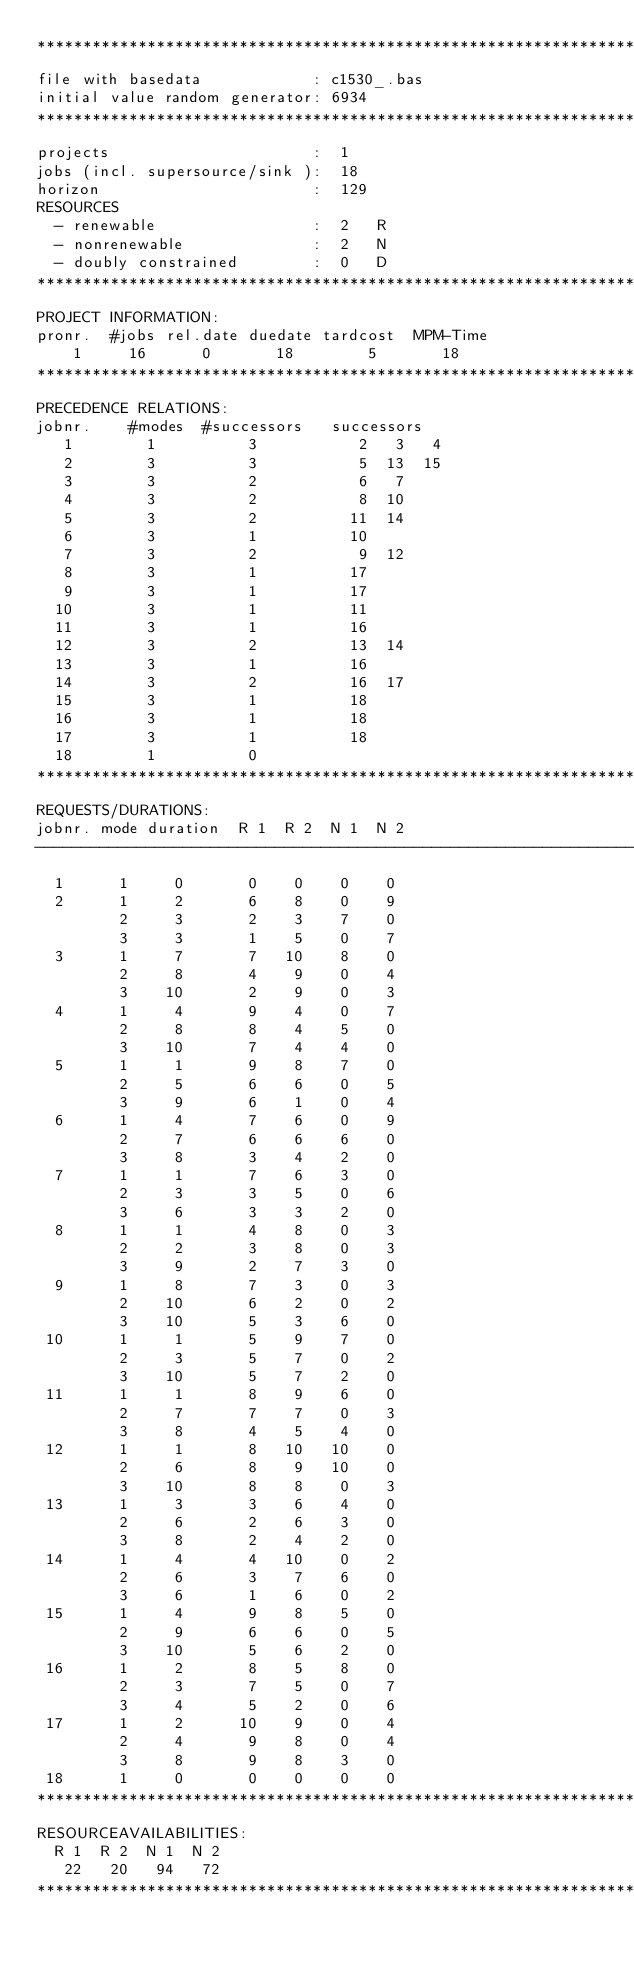<code> <loc_0><loc_0><loc_500><loc_500><_ObjectiveC_>************************************************************************
file with basedata            : c1530_.bas
initial value random generator: 6934
************************************************************************
projects                      :  1
jobs (incl. supersource/sink ):  18
horizon                       :  129
RESOURCES
  - renewable                 :  2   R
  - nonrenewable              :  2   N
  - doubly constrained        :  0   D
************************************************************************
PROJECT INFORMATION:
pronr.  #jobs rel.date duedate tardcost  MPM-Time
    1     16      0       18        5       18
************************************************************************
PRECEDENCE RELATIONS:
jobnr.    #modes  #successors   successors
   1        1          3           2   3   4
   2        3          3           5  13  15
   3        3          2           6   7
   4        3          2           8  10
   5        3          2          11  14
   6        3          1          10
   7        3          2           9  12
   8        3          1          17
   9        3          1          17
  10        3          1          11
  11        3          1          16
  12        3          2          13  14
  13        3          1          16
  14        3          2          16  17
  15        3          1          18
  16        3          1          18
  17        3          1          18
  18        1          0        
************************************************************************
REQUESTS/DURATIONS:
jobnr. mode duration  R 1  R 2  N 1  N 2
------------------------------------------------------------------------
  1      1     0       0    0    0    0
  2      1     2       6    8    0    9
         2     3       2    3    7    0
         3     3       1    5    0    7
  3      1     7       7   10    8    0
         2     8       4    9    0    4
         3    10       2    9    0    3
  4      1     4       9    4    0    7
         2     8       8    4    5    0
         3    10       7    4    4    0
  5      1     1       9    8    7    0
         2     5       6    6    0    5
         3     9       6    1    0    4
  6      1     4       7    6    0    9
         2     7       6    6    6    0
         3     8       3    4    2    0
  7      1     1       7    6    3    0
         2     3       3    5    0    6
         3     6       3    3    2    0
  8      1     1       4    8    0    3
         2     2       3    8    0    3
         3     9       2    7    3    0
  9      1     8       7    3    0    3
         2    10       6    2    0    2
         3    10       5    3    6    0
 10      1     1       5    9    7    0
         2     3       5    7    0    2
         3    10       5    7    2    0
 11      1     1       8    9    6    0
         2     7       7    7    0    3
         3     8       4    5    4    0
 12      1     1       8   10   10    0
         2     6       8    9   10    0
         3    10       8    8    0    3
 13      1     3       3    6    4    0
         2     6       2    6    3    0
         3     8       2    4    2    0
 14      1     4       4   10    0    2
         2     6       3    7    6    0
         3     6       1    6    0    2
 15      1     4       9    8    5    0
         2     9       6    6    0    5
         3    10       5    6    2    0
 16      1     2       8    5    8    0
         2     3       7    5    0    7
         3     4       5    2    0    6
 17      1     2      10    9    0    4
         2     4       9    8    0    4
         3     8       9    8    3    0
 18      1     0       0    0    0    0
************************************************************************
RESOURCEAVAILABILITIES:
  R 1  R 2  N 1  N 2
   22   20   94   72
************************************************************************
</code> 